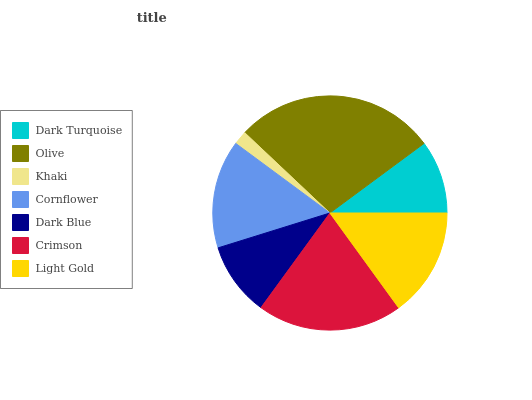Is Khaki the minimum?
Answer yes or no. Yes. Is Olive the maximum?
Answer yes or no. Yes. Is Olive the minimum?
Answer yes or no. No. Is Khaki the maximum?
Answer yes or no. No. Is Olive greater than Khaki?
Answer yes or no. Yes. Is Khaki less than Olive?
Answer yes or no. Yes. Is Khaki greater than Olive?
Answer yes or no. No. Is Olive less than Khaki?
Answer yes or no. No. Is Cornflower the high median?
Answer yes or no. Yes. Is Cornflower the low median?
Answer yes or no. Yes. Is Khaki the high median?
Answer yes or no. No. Is Khaki the low median?
Answer yes or no. No. 